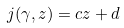<formula> <loc_0><loc_0><loc_500><loc_500>j ( \gamma , z ) = c z + d</formula> 